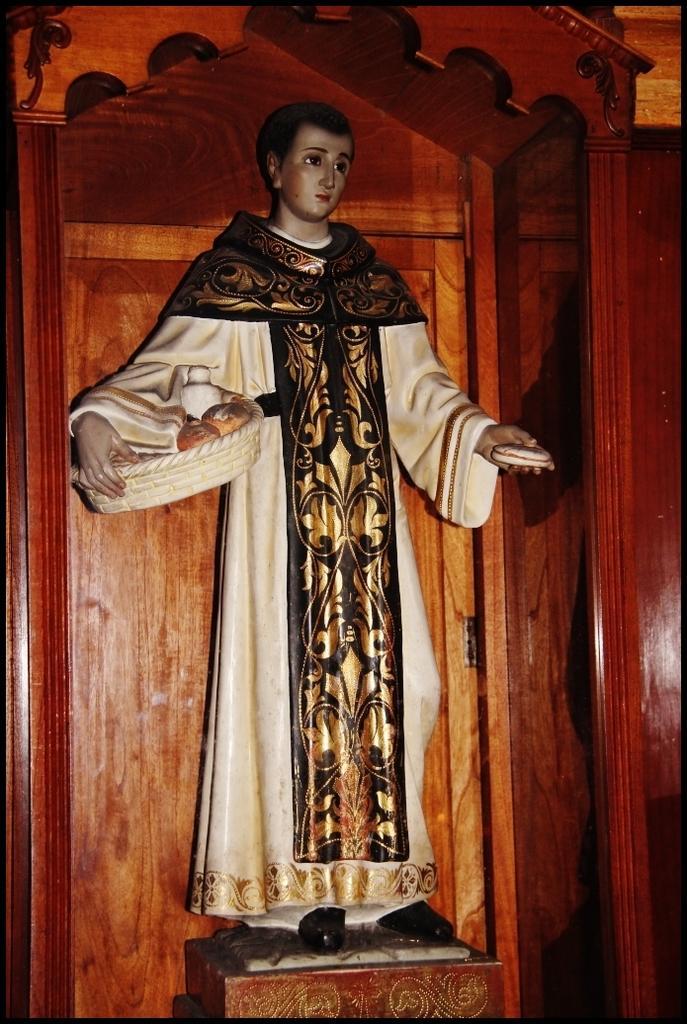Please provide a concise description of this image. There is a statue of a person wearing white dress and holding an object in his hands and the background is made of wood. 